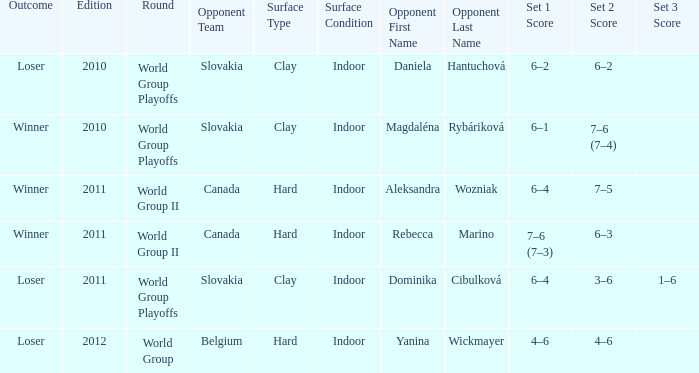What was the outcome of the game when the opponent was Magdaléna Rybáriková? Winner. 